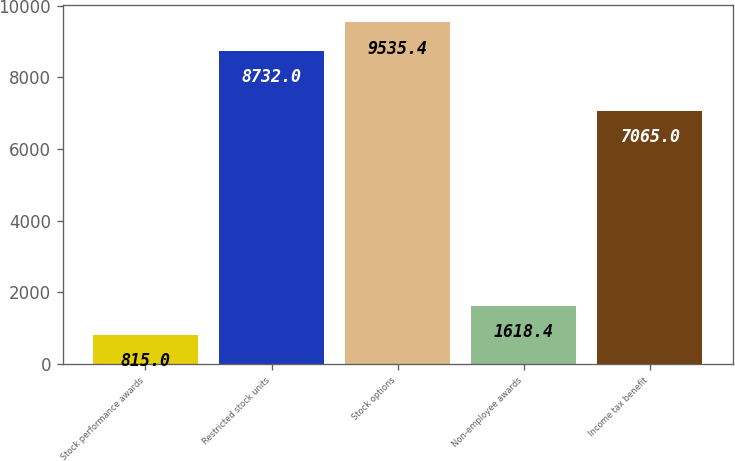<chart> <loc_0><loc_0><loc_500><loc_500><bar_chart><fcel>Stock performance awards<fcel>Restricted stock units<fcel>Stock options<fcel>Non-employee awards<fcel>Income tax benefit<nl><fcel>815<fcel>8732<fcel>9535.4<fcel>1618.4<fcel>7065<nl></chart> 